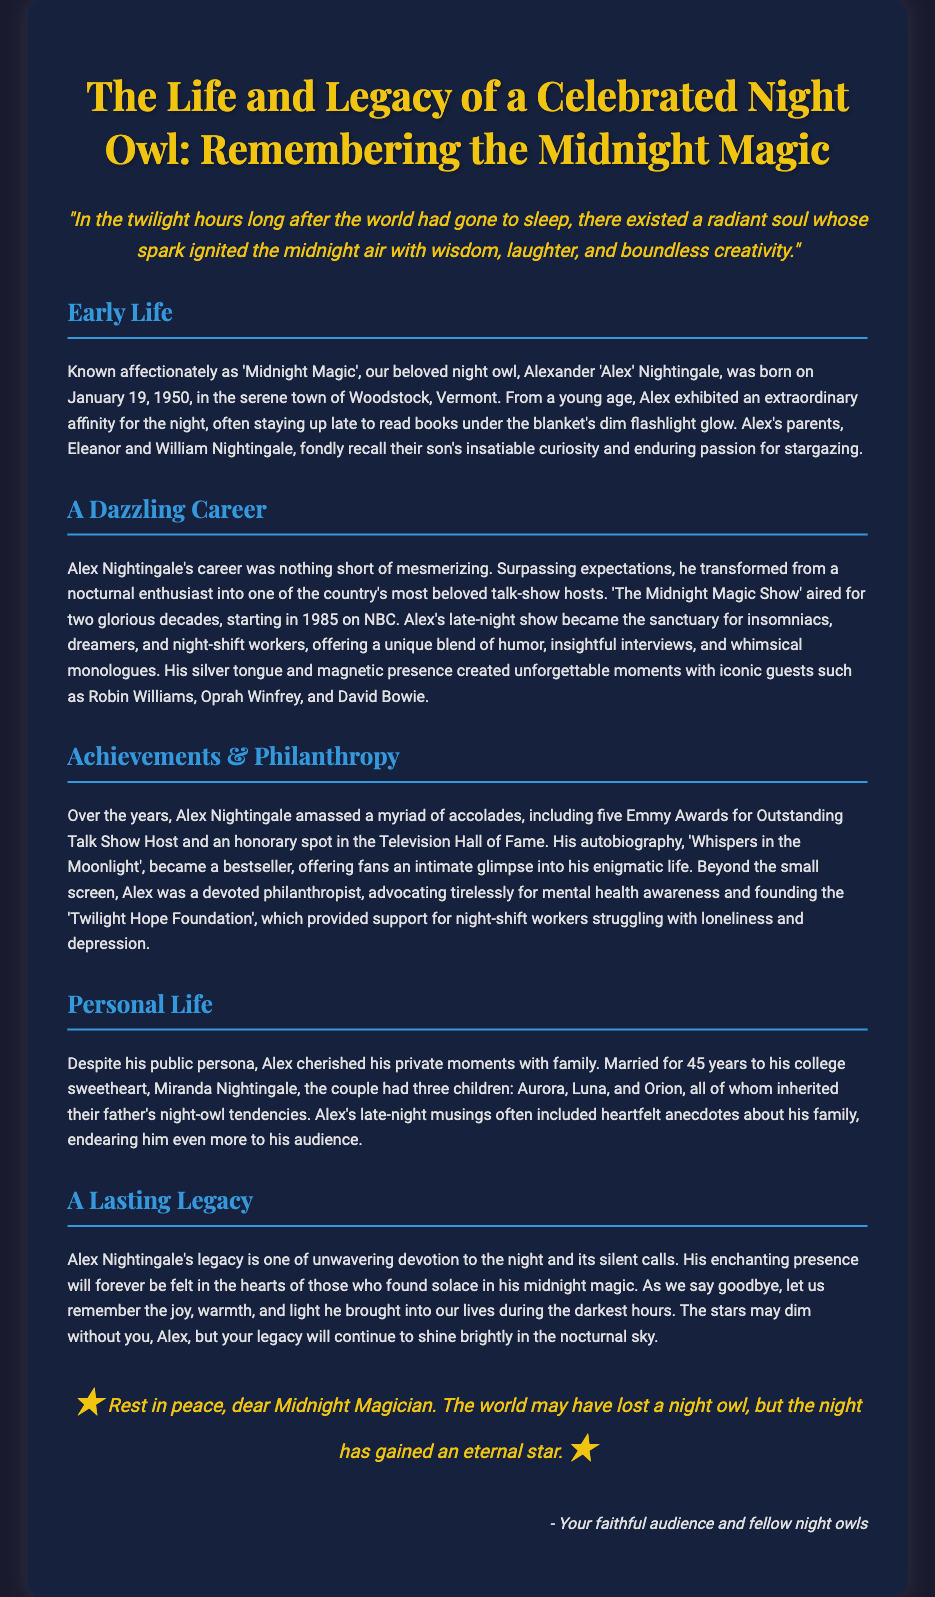What is the full name of the celebrated night owl? The document states that the celebrated night owl is Alexander 'Alex' Nightingale.
Answer: Alexander 'Alex' Nightingale When was Alex Nightingale born? The document mentions Alex was born on January 19, 1950.
Answer: January 19, 1950 What was the name of Alex's talk show? The document indicates that his talk show was titled 'The Midnight Magic Show'.
Answer: The Midnight Magic Show How many Emmy Awards did Alex Nightingale win? The document states Alex won five Emmy Awards for Outstanding Talk Show Host.
Answer: Five What foundation did Alex Nightingale found? The document reveals that he founded the 'Twilight Hope Foundation'.
Answer: Twilight Hope Foundation In what year did 'The Midnight Magic Show' first air? The document mentions that the show started airing in 1985.
Answer: 1985 What were the names of Alex's three children? The document lists the names of his children as Aurora, Luna, and Orion.
Answer: Aurora, Luna, and Orion What was the title of Alex Nightingale's autobiography? The document states that his autobiography is titled 'Whispers in the Moonlight'.
Answer: Whispers in the Moonlight What theme is prominently featured in Alex's legacy? The document highlights an unwavering devotion to the night and its silent calls in Alex's legacy.
Answer: Devotion to the night 